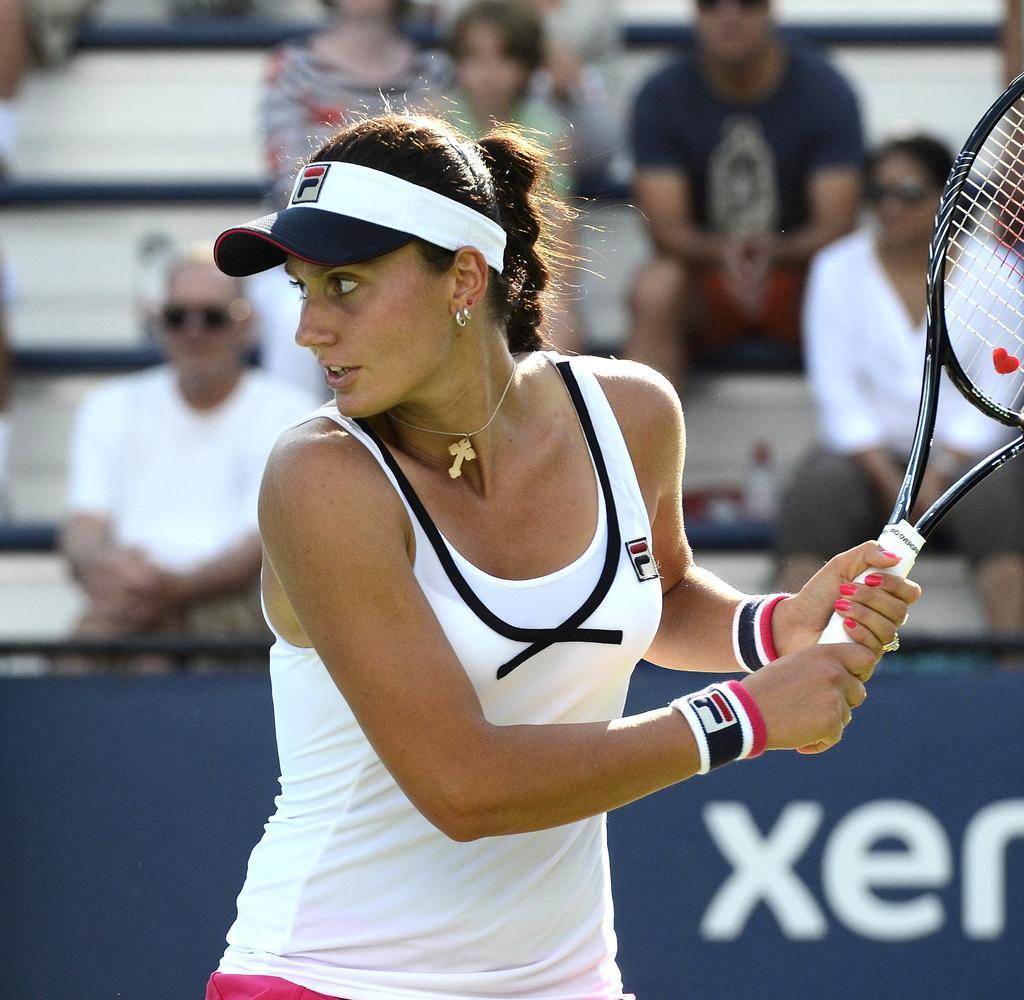Could you give a brief overview of what you see in this image? In this image, in the middle there is a woman she is standing and holding a bat which is in white color, in the background there is a poster in blue color and there are some people sitting on the chairs. 